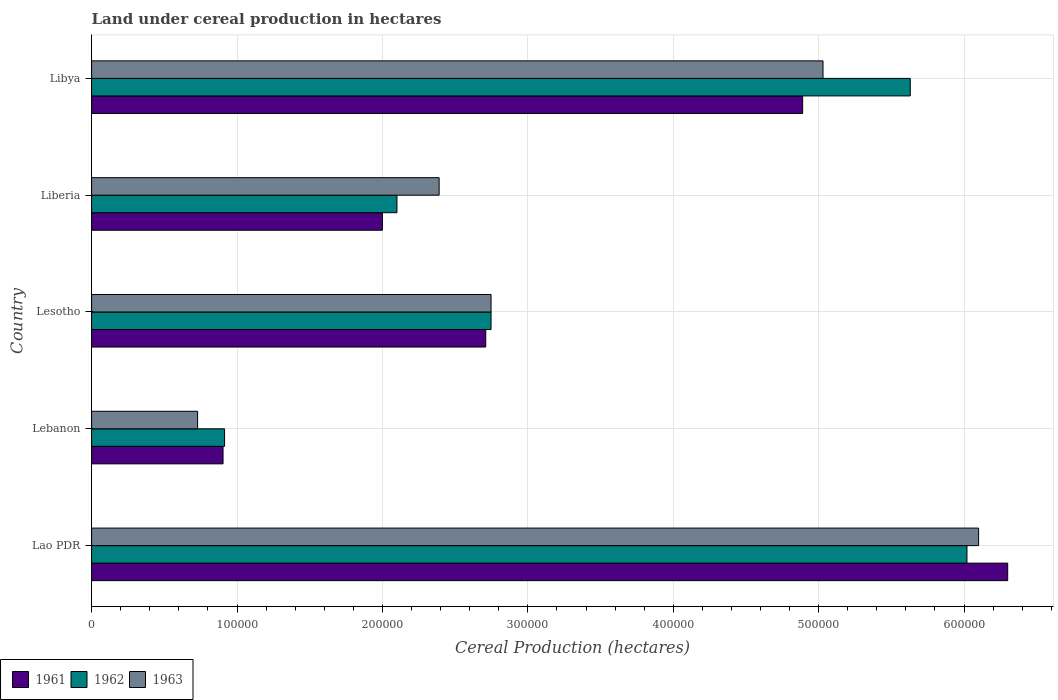Are the number of bars per tick equal to the number of legend labels?
Make the answer very short. Yes. How many bars are there on the 2nd tick from the top?
Offer a very short reply. 3. How many bars are there on the 3rd tick from the bottom?
Offer a terse response. 3. What is the label of the 3rd group of bars from the top?
Provide a short and direct response. Lesotho. What is the land under cereal production in 1961 in Lao PDR?
Offer a very short reply. 6.30e+05. Across all countries, what is the maximum land under cereal production in 1961?
Your answer should be compact. 6.30e+05. Across all countries, what is the minimum land under cereal production in 1961?
Your answer should be compact. 9.04e+04. In which country was the land under cereal production in 1962 maximum?
Your answer should be very brief. Lao PDR. In which country was the land under cereal production in 1963 minimum?
Provide a short and direct response. Lebanon. What is the total land under cereal production in 1961 in the graph?
Ensure brevity in your answer.  1.68e+06. What is the difference between the land under cereal production in 1962 in Lesotho and that in Libya?
Your answer should be very brief. -2.88e+05. What is the difference between the land under cereal production in 1962 in Lao PDR and the land under cereal production in 1961 in Libya?
Offer a terse response. 1.13e+05. What is the average land under cereal production in 1961 per country?
Offer a very short reply. 3.36e+05. What is the ratio of the land under cereal production in 1961 in Lao PDR to that in Libya?
Give a very brief answer. 1.29. What is the difference between the highest and the second highest land under cereal production in 1961?
Make the answer very short. 1.41e+05. What is the difference between the highest and the lowest land under cereal production in 1961?
Keep it short and to the point. 5.40e+05. In how many countries, is the land under cereal production in 1961 greater than the average land under cereal production in 1961 taken over all countries?
Ensure brevity in your answer.  2. Is the sum of the land under cereal production in 1962 in Lao PDR and Libya greater than the maximum land under cereal production in 1961 across all countries?
Keep it short and to the point. Yes. What does the 3rd bar from the top in Libya represents?
Give a very brief answer. 1961. Is it the case that in every country, the sum of the land under cereal production in 1961 and land under cereal production in 1962 is greater than the land under cereal production in 1963?
Offer a terse response. Yes. Are all the bars in the graph horizontal?
Offer a very short reply. Yes. How many countries are there in the graph?
Keep it short and to the point. 5. Are the values on the major ticks of X-axis written in scientific E-notation?
Provide a short and direct response. No. How many legend labels are there?
Make the answer very short. 3. How are the legend labels stacked?
Keep it short and to the point. Horizontal. What is the title of the graph?
Your response must be concise. Land under cereal production in hectares. What is the label or title of the X-axis?
Ensure brevity in your answer.  Cereal Production (hectares). What is the label or title of the Y-axis?
Make the answer very short. Country. What is the Cereal Production (hectares) in 1961 in Lao PDR?
Provide a short and direct response. 6.30e+05. What is the Cereal Production (hectares) in 1962 in Lao PDR?
Offer a terse response. 6.02e+05. What is the Cereal Production (hectares) of 1961 in Lebanon?
Your answer should be compact. 9.04e+04. What is the Cereal Production (hectares) of 1962 in Lebanon?
Make the answer very short. 9.14e+04. What is the Cereal Production (hectares) of 1963 in Lebanon?
Give a very brief answer. 7.29e+04. What is the Cereal Production (hectares) of 1961 in Lesotho?
Provide a succinct answer. 2.71e+05. What is the Cereal Production (hectares) in 1962 in Lesotho?
Your answer should be very brief. 2.75e+05. What is the Cereal Production (hectares) in 1963 in Lesotho?
Make the answer very short. 2.75e+05. What is the Cereal Production (hectares) in 1962 in Liberia?
Ensure brevity in your answer.  2.10e+05. What is the Cereal Production (hectares) of 1963 in Liberia?
Keep it short and to the point. 2.39e+05. What is the Cereal Production (hectares) of 1961 in Libya?
Your response must be concise. 4.89e+05. What is the Cereal Production (hectares) in 1962 in Libya?
Offer a terse response. 5.63e+05. What is the Cereal Production (hectares) of 1963 in Libya?
Your answer should be compact. 5.03e+05. Across all countries, what is the maximum Cereal Production (hectares) of 1961?
Provide a succinct answer. 6.30e+05. Across all countries, what is the maximum Cereal Production (hectares) of 1962?
Keep it short and to the point. 6.02e+05. Across all countries, what is the minimum Cereal Production (hectares) in 1961?
Make the answer very short. 9.04e+04. Across all countries, what is the minimum Cereal Production (hectares) in 1962?
Keep it short and to the point. 9.14e+04. Across all countries, what is the minimum Cereal Production (hectares) of 1963?
Offer a very short reply. 7.29e+04. What is the total Cereal Production (hectares) of 1961 in the graph?
Offer a very short reply. 1.68e+06. What is the total Cereal Production (hectares) in 1962 in the graph?
Give a very brief answer. 1.74e+06. What is the total Cereal Production (hectares) of 1963 in the graph?
Ensure brevity in your answer.  1.70e+06. What is the difference between the Cereal Production (hectares) in 1961 in Lao PDR and that in Lebanon?
Your response must be concise. 5.40e+05. What is the difference between the Cereal Production (hectares) in 1962 in Lao PDR and that in Lebanon?
Offer a very short reply. 5.11e+05. What is the difference between the Cereal Production (hectares) in 1963 in Lao PDR and that in Lebanon?
Provide a succinct answer. 5.37e+05. What is the difference between the Cereal Production (hectares) of 1961 in Lao PDR and that in Lesotho?
Your answer should be compact. 3.59e+05. What is the difference between the Cereal Production (hectares) in 1962 in Lao PDR and that in Lesotho?
Offer a very short reply. 3.27e+05. What is the difference between the Cereal Production (hectares) in 1963 in Lao PDR and that in Lesotho?
Keep it short and to the point. 3.35e+05. What is the difference between the Cereal Production (hectares) of 1962 in Lao PDR and that in Liberia?
Ensure brevity in your answer.  3.92e+05. What is the difference between the Cereal Production (hectares) in 1963 in Lao PDR and that in Liberia?
Provide a succinct answer. 3.71e+05. What is the difference between the Cereal Production (hectares) in 1961 in Lao PDR and that in Libya?
Keep it short and to the point. 1.41e+05. What is the difference between the Cereal Production (hectares) in 1962 in Lao PDR and that in Libya?
Your answer should be very brief. 3.90e+04. What is the difference between the Cereal Production (hectares) of 1963 in Lao PDR and that in Libya?
Ensure brevity in your answer.  1.07e+05. What is the difference between the Cereal Production (hectares) of 1961 in Lebanon and that in Lesotho?
Your answer should be very brief. -1.81e+05. What is the difference between the Cereal Production (hectares) in 1962 in Lebanon and that in Lesotho?
Ensure brevity in your answer.  -1.83e+05. What is the difference between the Cereal Production (hectares) of 1963 in Lebanon and that in Lesotho?
Keep it short and to the point. -2.02e+05. What is the difference between the Cereal Production (hectares) of 1961 in Lebanon and that in Liberia?
Provide a short and direct response. -1.10e+05. What is the difference between the Cereal Production (hectares) of 1962 in Lebanon and that in Liberia?
Give a very brief answer. -1.19e+05. What is the difference between the Cereal Production (hectares) in 1963 in Lebanon and that in Liberia?
Give a very brief answer. -1.66e+05. What is the difference between the Cereal Production (hectares) in 1961 in Lebanon and that in Libya?
Keep it short and to the point. -3.99e+05. What is the difference between the Cereal Production (hectares) of 1962 in Lebanon and that in Libya?
Your answer should be very brief. -4.72e+05. What is the difference between the Cereal Production (hectares) in 1963 in Lebanon and that in Libya?
Offer a terse response. -4.30e+05. What is the difference between the Cereal Production (hectares) of 1961 in Lesotho and that in Liberia?
Give a very brief answer. 7.11e+04. What is the difference between the Cereal Production (hectares) in 1962 in Lesotho and that in Liberia?
Offer a very short reply. 6.47e+04. What is the difference between the Cereal Production (hectares) in 1963 in Lesotho and that in Liberia?
Provide a short and direct response. 3.57e+04. What is the difference between the Cereal Production (hectares) of 1961 in Lesotho and that in Libya?
Give a very brief answer. -2.18e+05. What is the difference between the Cereal Production (hectares) in 1962 in Lesotho and that in Libya?
Give a very brief answer. -2.88e+05. What is the difference between the Cereal Production (hectares) of 1963 in Lesotho and that in Libya?
Keep it short and to the point. -2.28e+05. What is the difference between the Cereal Production (hectares) in 1961 in Liberia and that in Libya?
Offer a very short reply. -2.89e+05. What is the difference between the Cereal Production (hectares) of 1962 in Liberia and that in Libya?
Ensure brevity in your answer.  -3.53e+05. What is the difference between the Cereal Production (hectares) of 1963 in Liberia and that in Libya?
Your answer should be compact. -2.64e+05. What is the difference between the Cereal Production (hectares) in 1961 in Lao PDR and the Cereal Production (hectares) in 1962 in Lebanon?
Give a very brief answer. 5.39e+05. What is the difference between the Cereal Production (hectares) of 1961 in Lao PDR and the Cereal Production (hectares) of 1963 in Lebanon?
Your answer should be compact. 5.57e+05. What is the difference between the Cereal Production (hectares) of 1962 in Lao PDR and the Cereal Production (hectares) of 1963 in Lebanon?
Keep it short and to the point. 5.29e+05. What is the difference between the Cereal Production (hectares) of 1961 in Lao PDR and the Cereal Production (hectares) of 1962 in Lesotho?
Offer a terse response. 3.55e+05. What is the difference between the Cereal Production (hectares) of 1961 in Lao PDR and the Cereal Production (hectares) of 1963 in Lesotho?
Make the answer very short. 3.55e+05. What is the difference between the Cereal Production (hectares) of 1962 in Lao PDR and the Cereal Production (hectares) of 1963 in Lesotho?
Provide a succinct answer. 3.27e+05. What is the difference between the Cereal Production (hectares) in 1961 in Lao PDR and the Cereal Production (hectares) in 1962 in Liberia?
Your response must be concise. 4.20e+05. What is the difference between the Cereal Production (hectares) in 1961 in Lao PDR and the Cereal Production (hectares) in 1963 in Liberia?
Provide a short and direct response. 3.91e+05. What is the difference between the Cereal Production (hectares) of 1962 in Lao PDR and the Cereal Production (hectares) of 1963 in Liberia?
Your answer should be very brief. 3.63e+05. What is the difference between the Cereal Production (hectares) in 1961 in Lao PDR and the Cereal Production (hectares) in 1962 in Libya?
Provide a short and direct response. 6.70e+04. What is the difference between the Cereal Production (hectares) of 1961 in Lao PDR and the Cereal Production (hectares) of 1963 in Libya?
Make the answer very short. 1.27e+05. What is the difference between the Cereal Production (hectares) of 1962 in Lao PDR and the Cereal Production (hectares) of 1963 in Libya?
Give a very brief answer. 9.90e+04. What is the difference between the Cereal Production (hectares) of 1961 in Lebanon and the Cereal Production (hectares) of 1962 in Lesotho?
Make the answer very short. -1.84e+05. What is the difference between the Cereal Production (hectares) in 1961 in Lebanon and the Cereal Production (hectares) in 1963 in Lesotho?
Offer a terse response. -1.84e+05. What is the difference between the Cereal Production (hectares) in 1962 in Lebanon and the Cereal Production (hectares) in 1963 in Lesotho?
Your answer should be very brief. -1.83e+05. What is the difference between the Cereal Production (hectares) of 1961 in Lebanon and the Cereal Production (hectares) of 1962 in Liberia?
Offer a very short reply. -1.20e+05. What is the difference between the Cereal Production (hectares) of 1961 in Lebanon and the Cereal Production (hectares) of 1963 in Liberia?
Keep it short and to the point. -1.49e+05. What is the difference between the Cereal Production (hectares) in 1962 in Lebanon and the Cereal Production (hectares) in 1963 in Liberia?
Your answer should be compact. -1.48e+05. What is the difference between the Cereal Production (hectares) of 1961 in Lebanon and the Cereal Production (hectares) of 1962 in Libya?
Keep it short and to the point. -4.73e+05. What is the difference between the Cereal Production (hectares) of 1961 in Lebanon and the Cereal Production (hectares) of 1963 in Libya?
Your answer should be very brief. -4.13e+05. What is the difference between the Cereal Production (hectares) in 1962 in Lebanon and the Cereal Production (hectares) in 1963 in Libya?
Your answer should be compact. -4.12e+05. What is the difference between the Cereal Production (hectares) in 1961 in Lesotho and the Cereal Production (hectares) in 1962 in Liberia?
Your response must be concise. 6.11e+04. What is the difference between the Cereal Production (hectares) of 1961 in Lesotho and the Cereal Production (hectares) of 1963 in Liberia?
Provide a succinct answer. 3.21e+04. What is the difference between the Cereal Production (hectares) of 1962 in Lesotho and the Cereal Production (hectares) of 1963 in Liberia?
Provide a short and direct response. 3.57e+04. What is the difference between the Cereal Production (hectares) of 1961 in Lesotho and the Cereal Production (hectares) of 1962 in Libya?
Keep it short and to the point. -2.92e+05. What is the difference between the Cereal Production (hectares) of 1961 in Lesotho and the Cereal Production (hectares) of 1963 in Libya?
Make the answer very short. -2.32e+05. What is the difference between the Cereal Production (hectares) in 1962 in Lesotho and the Cereal Production (hectares) in 1963 in Libya?
Your answer should be compact. -2.28e+05. What is the difference between the Cereal Production (hectares) in 1961 in Liberia and the Cereal Production (hectares) in 1962 in Libya?
Ensure brevity in your answer.  -3.63e+05. What is the difference between the Cereal Production (hectares) of 1961 in Liberia and the Cereal Production (hectares) of 1963 in Libya?
Your answer should be compact. -3.03e+05. What is the difference between the Cereal Production (hectares) in 1962 in Liberia and the Cereal Production (hectares) in 1963 in Libya?
Keep it short and to the point. -2.93e+05. What is the average Cereal Production (hectares) in 1961 per country?
Offer a terse response. 3.36e+05. What is the average Cereal Production (hectares) in 1962 per country?
Ensure brevity in your answer.  3.48e+05. What is the average Cereal Production (hectares) of 1963 per country?
Your answer should be very brief. 3.40e+05. What is the difference between the Cereal Production (hectares) of 1961 and Cereal Production (hectares) of 1962 in Lao PDR?
Ensure brevity in your answer.  2.80e+04. What is the difference between the Cereal Production (hectares) in 1961 and Cereal Production (hectares) in 1963 in Lao PDR?
Make the answer very short. 2.00e+04. What is the difference between the Cereal Production (hectares) of 1962 and Cereal Production (hectares) of 1963 in Lao PDR?
Offer a terse response. -8000. What is the difference between the Cereal Production (hectares) in 1961 and Cereal Production (hectares) in 1962 in Lebanon?
Provide a succinct answer. -1035. What is the difference between the Cereal Production (hectares) of 1961 and Cereal Production (hectares) of 1963 in Lebanon?
Your answer should be very brief. 1.75e+04. What is the difference between the Cereal Production (hectares) of 1962 and Cereal Production (hectares) of 1963 in Lebanon?
Make the answer very short. 1.85e+04. What is the difference between the Cereal Production (hectares) of 1961 and Cereal Production (hectares) of 1962 in Lesotho?
Your answer should be compact. -3641. What is the difference between the Cereal Production (hectares) of 1961 and Cereal Production (hectares) of 1963 in Lesotho?
Your answer should be very brief. -3641. What is the difference between the Cereal Production (hectares) in 1961 and Cereal Production (hectares) in 1962 in Liberia?
Provide a short and direct response. -10000. What is the difference between the Cereal Production (hectares) in 1961 and Cereal Production (hectares) in 1963 in Liberia?
Provide a succinct answer. -3.90e+04. What is the difference between the Cereal Production (hectares) of 1962 and Cereal Production (hectares) of 1963 in Liberia?
Keep it short and to the point. -2.90e+04. What is the difference between the Cereal Production (hectares) of 1961 and Cereal Production (hectares) of 1962 in Libya?
Keep it short and to the point. -7.40e+04. What is the difference between the Cereal Production (hectares) of 1961 and Cereal Production (hectares) of 1963 in Libya?
Your answer should be compact. -1.40e+04. What is the ratio of the Cereal Production (hectares) of 1961 in Lao PDR to that in Lebanon?
Your answer should be very brief. 6.97. What is the ratio of the Cereal Production (hectares) in 1962 in Lao PDR to that in Lebanon?
Your response must be concise. 6.58. What is the ratio of the Cereal Production (hectares) of 1963 in Lao PDR to that in Lebanon?
Provide a succinct answer. 8.37. What is the ratio of the Cereal Production (hectares) of 1961 in Lao PDR to that in Lesotho?
Offer a very short reply. 2.32. What is the ratio of the Cereal Production (hectares) of 1962 in Lao PDR to that in Lesotho?
Your answer should be compact. 2.19. What is the ratio of the Cereal Production (hectares) in 1963 in Lao PDR to that in Lesotho?
Your answer should be compact. 2.22. What is the ratio of the Cereal Production (hectares) in 1961 in Lao PDR to that in Liberia?
Ensure brevity in your answer.  3.15. What is the ratio of the Cereal Production (hectares) of 1962 in Lao PDR to that in Liberia?
Provide a short and direct response. 2.87. What is the ratio of the Cereal Production (hectares) of 1963 in Lao PDR to that in Liberia?
Your response must be concise. 2.55. What is the ratio of the Cereal Production (hectares) of 1961 in Lao PDR to that in Libya?
Offer a terse response. 1.29. What is the ratio of the Cereal Production (hectares) in 1962 in Lao PDR to that in Libya?
Give a very brief answer. 1.07. What is the ratio of the Cereal Production (hectares) in 1963 in Lao PDR to that in Libya?
Offer a very short reply. 1.21. What is the ratio of the Cereal Production (hectares) of 1961 in Lebanon to that in Lesotho?
Your answer should be compact. 0.33. What is the ratio of the Cereal Production (hectares) in 1962 in Lebanon to that in Lesotho?
Give a very brief answer. 0.33. What is the ratio of the Cereal Production (hectares) of 1963 in Lebanon to that in Lesotho?
Your answer should be very brief. 0.27. What is the ratio of the Cereal Production (hectares) of 1961 in Lebanon to that in Liberia?
Make the answer very short. 0.45. What is the ratio of the Cereal Production (hectares) in 1962 in Lebanon to that in Liberia?
Keep it short and to the point. 0.44. What is the ratio of the Cereal Production (hectares) of 1963 in Lebanon to that in Liberia?
Keep it short and to the point. 0.3. What is the ratio of the Cereal Production (hectares) in 1961 in Lebanon to that in Libya?
Provide a short and direct response. 0.18. What is the ratio of the Cereal Production (hectares) in 1962 in Lebanon to that in Libya?
Give a very brief answer. 0.16. What is the ratio of the Cereal Production (hectares) in 1963 in Lebanon to that in Libya?
Your answer should be compact. 0.14. What is the ratio of the Cereal Production (hectares) of 1961 in Lesotho to that in Liberia?
Keep it short and to the point. 1.36. What is the ratio of the Cereal Production (hectares) in 1962 in Lesotho to that in Liberia?
Provide a succinct answer. 1.31. What is the ratio of the Cereal Production (hectares) of 1963 in Lesotho to that in Liberia?
Provide a succinct answer. 1.15. What is the ratio of the Cereal Production (hectares) of 1961 in Lesotho to that in Libya?
Offer a terse response. 0.55. What is the ratio of the Cereal Production (hectares) in 1962 in Lesotho to that in Libya?
Offer a very short reply. 0.49. What is the ratio of the Cereal Production (hectares) of 1963 in Lesotho to that in Libya?
Your answer should be compact. 0.55. What is the ratio of the Cereal Production (hectares) in 1961 in Liberia to that in Libya?
Your answer should be compact. 0.41. What is the ratio of the Cereal Production (hectares) in 1962 in Liberia to that in Libya?
Your answer should be compact. 0.37. What is the ratio of the Cereal Production (hectares) of 1963 in Liberia to that in Libya?
Ensure brevity in your answer.  0.48. What is the difference between the highest and the second highest Cereal Production (hectares) of 1961?
Offer a terse response. 1.41e+05. What is the difference between the highest and the second highest Cereal Production (hectares) in 1962?
Your answer should be very brief. 3.90e+04. What is the difference between the highest and the second highest Cereal Production (hectares) of 1963?
Give a very brief answer. 1.07e+05. What is the difference between the highest and the lowest Cereal Production (hectares) of 1961?
Ensure brevity in your answer.  5.40e+05. What is the difference between the highest and the lowest Cereal Production (hectares) in 1962?
Keep it short and to the point. 5.11e+05. What is the difference between the highest and the lowest Cereal Production (hectares) of 1963?
Provide a short and direct response. 5.37e+05. 